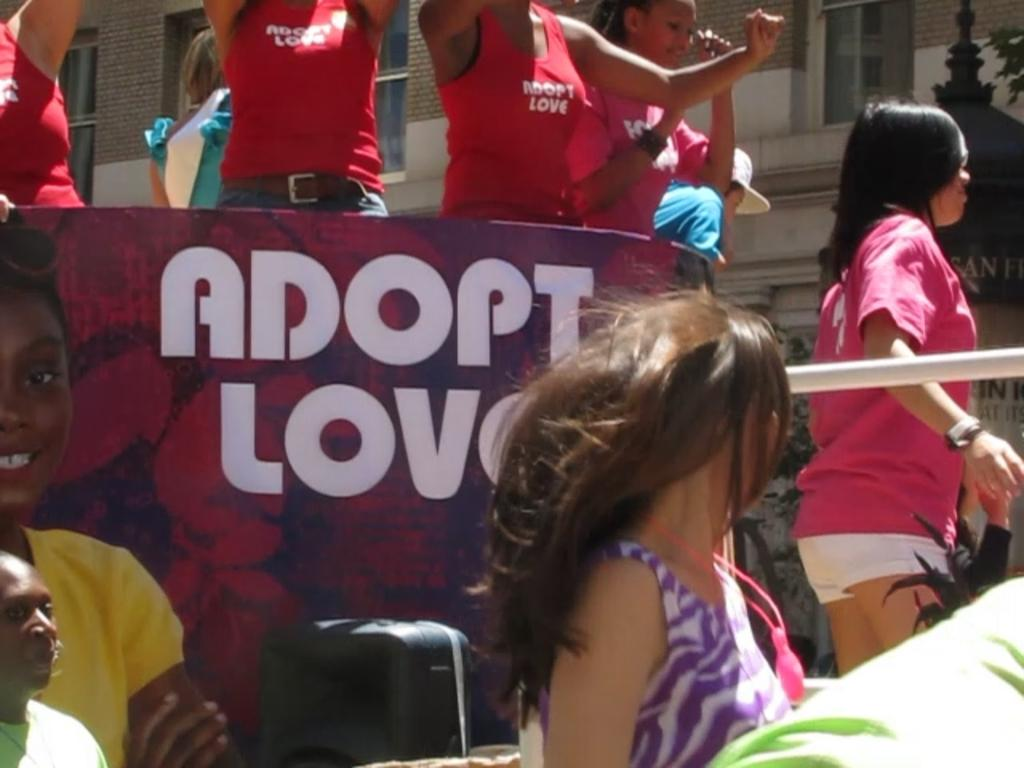<image>
Create a compact narrative representing the image presented. Adopt love on a banner and on red shirts. 